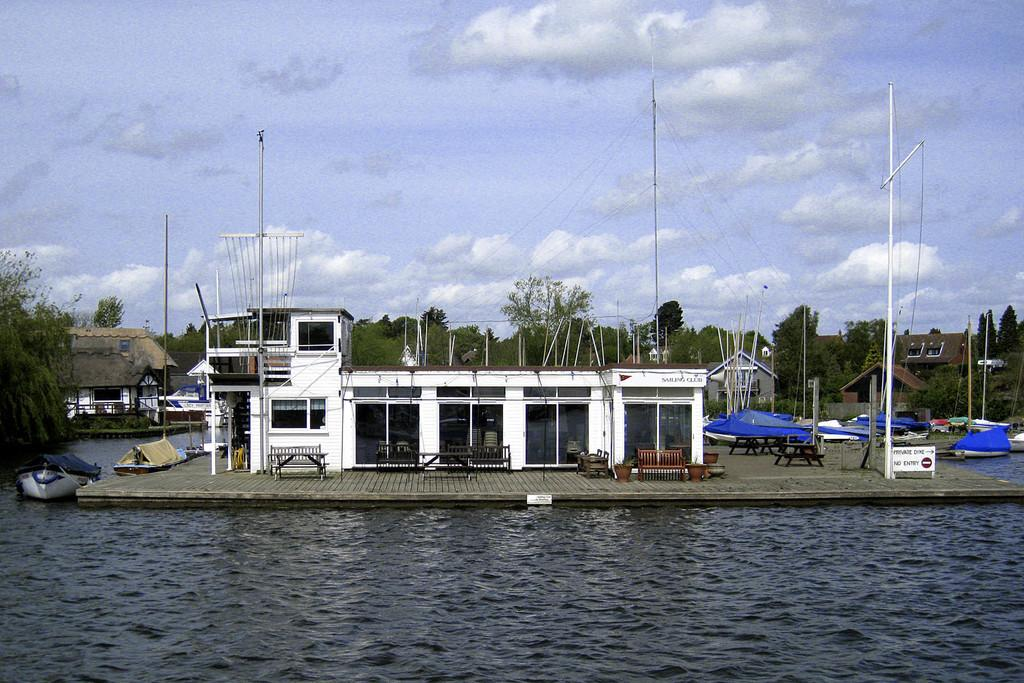What is the primary element visible in the image? There is water in the image. What else can be seen in the water? There are boats in the image. What type of structures are visible near the water? There are houses in the image. Are there any objects for sitting in the image? Yes, there are chairs in the image. What can be seen in the background of the image? There are trees in the background of the image. What else is present in the image besides the water, boats, houses, chairs, and trees? There are poles in the image. What is the texture of the sugar in the image? There is no sugar present in the image, so it is not possible to determine its texture. 